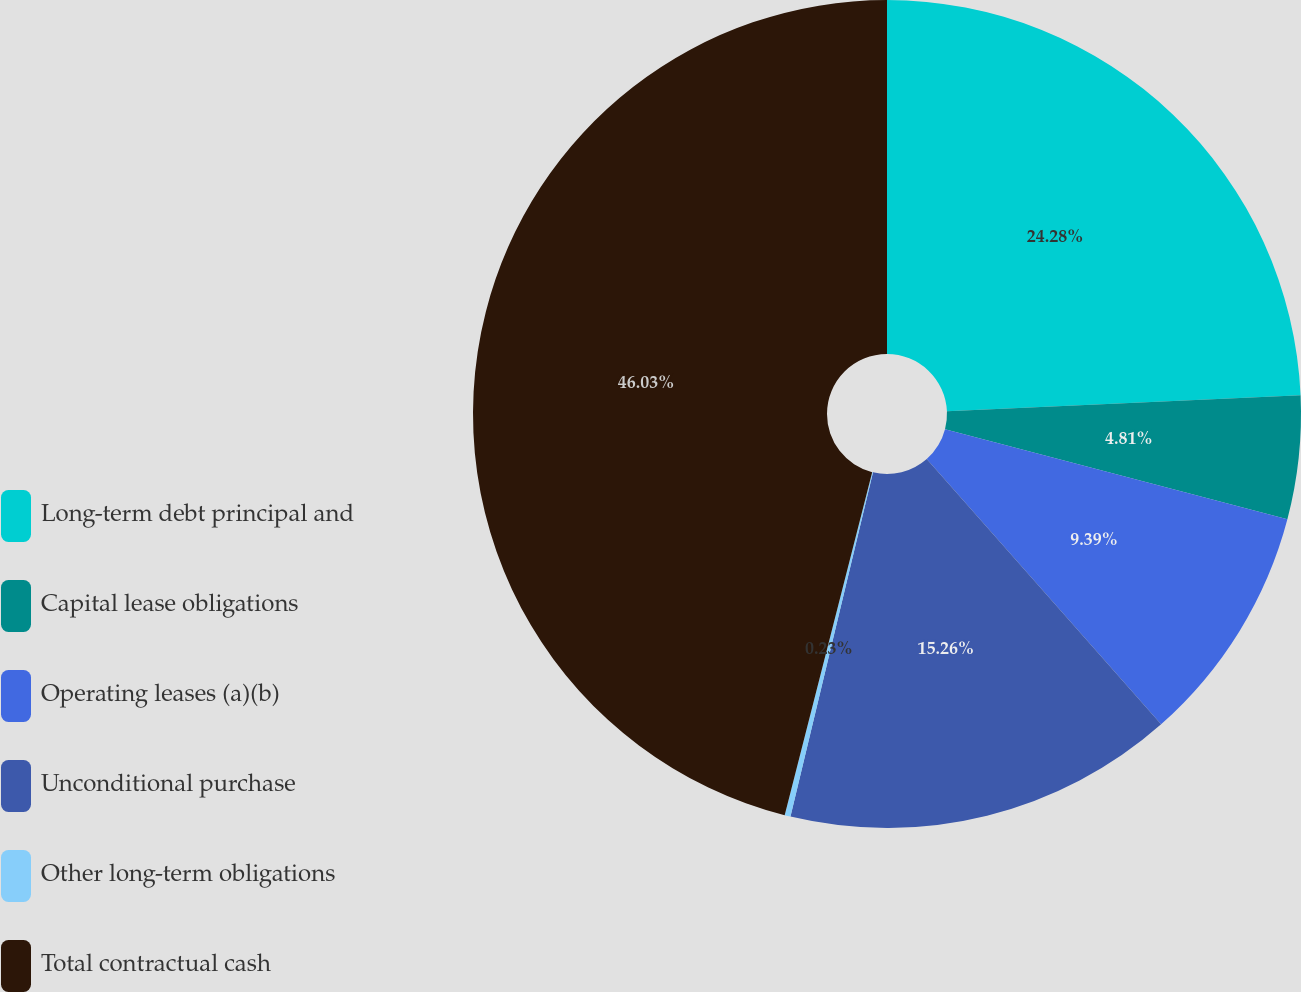Convert chart. <chart><loc_0><loc_0><loc_500><loc_500><pie_chart><fcel>Long-term debt principal and<fcel>Capital lease obligations<fcel>Operating leases (a)(b)<fcel>Unconditional purchase<fcel>Other long-term obligations<fcel>Total contractual cash<nl><fcel>24.28%<fcel>4.81%<fcel>9.39%<fcel>15.26%<fcel>0.23%<fcel>46.02%<nl></chart> 